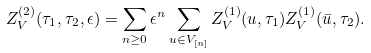Convert formula to latex. <formula><loc_0><loc_0><loc_500><loc_500>Z _ { V } ^ { ( 2 ) } ( \tau _ { 1 } , \tau _ { 2 } , \epsilon ) = \sum _ { n \geq 0 } \epsilon ^ { n } \sum _ { u \in V _ { [ n ] } } Z _ { V } ^ { ( 1 ) } ( u , \tau _ { 1 } ) Z _ { V } ^ { ( 1 ) } ( \bar { u } , \tau _ { 2 } ) .</formula> 